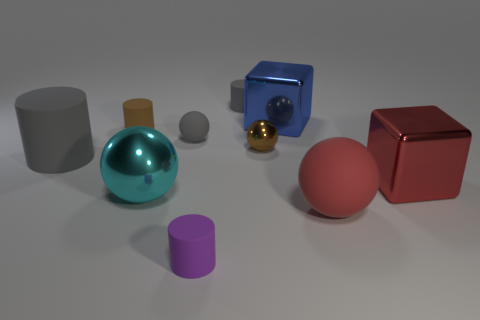There is a matte cylinder in front of the big rubber thing right of the large gray matte cylinder; how big is it?
Offer a terse response. Small. Is there any other thing that is the same size as the red rubber thing?
Ensure brevity in your answer.  Yes. There is a gray thing that is the same shape as the tiny brown metallic object; what is its material?
Make the answer very short. Rubber. Does the big red thing that is in front of the big metal sphere have the same shape as the large object that is behind the large matte cylinder?
Provide a succinct answer. No. Are there more red metallic blocks than tiny green rubber cubes?
Make the answer very short. Yes. What is the size of the red rubber object?
Keep it short and to the point. Large. How many other things are there of the same color as the large rubber cylinder?
Your answer should be compact. 2. Is the material of the block that is behind the small brown metallic object the same as the tiny gray sphere?
Make the answer very short. No. Is the number of small gray objects to the left of the tiny brown matte cylinder less than the number of small gray objects that are behind the brown metallic sphere?
Your response must be concise. Yes. What number of other objects are there of the same material as the big blue object?
Offer a terse response. 3. 